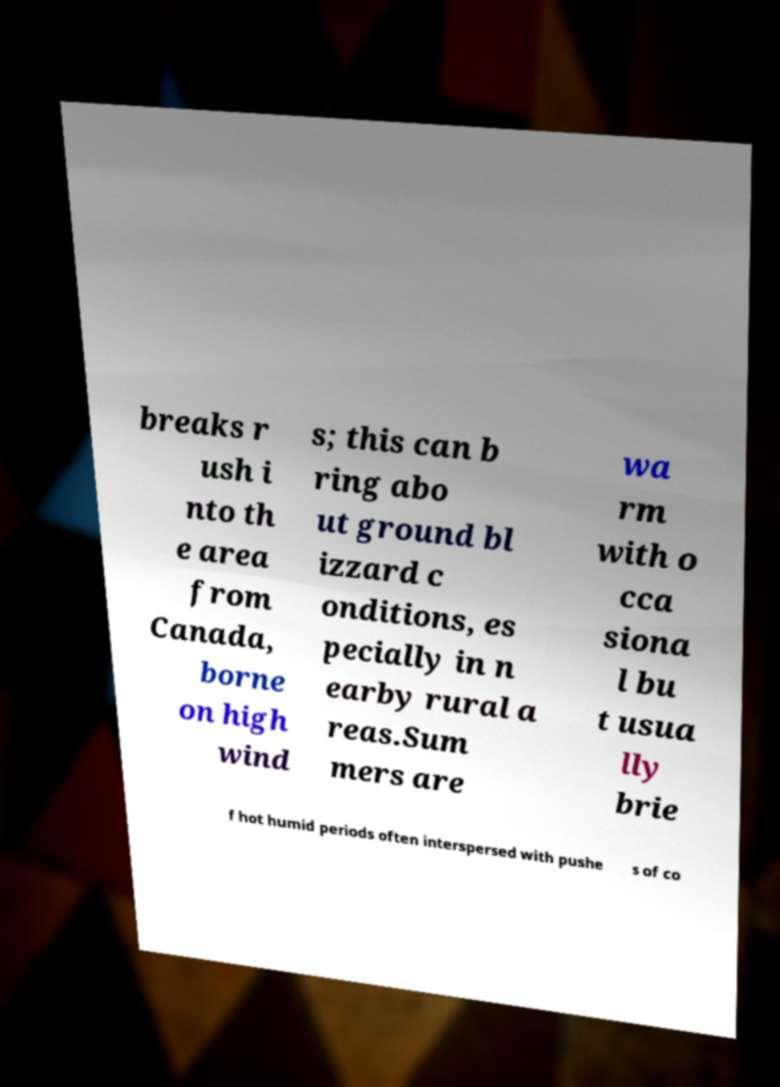Could you extract and type out the text from this image? breaks r ush i nto th e area from Canada, borne on high wind s; this can b ring abo ut ground bl izzard c onditions, es pecially in n earby rural a reas.Sum mers are wa rm with o cca siona l bu t usua lly brie f hot humid periods often interspersed with pushe s of co 